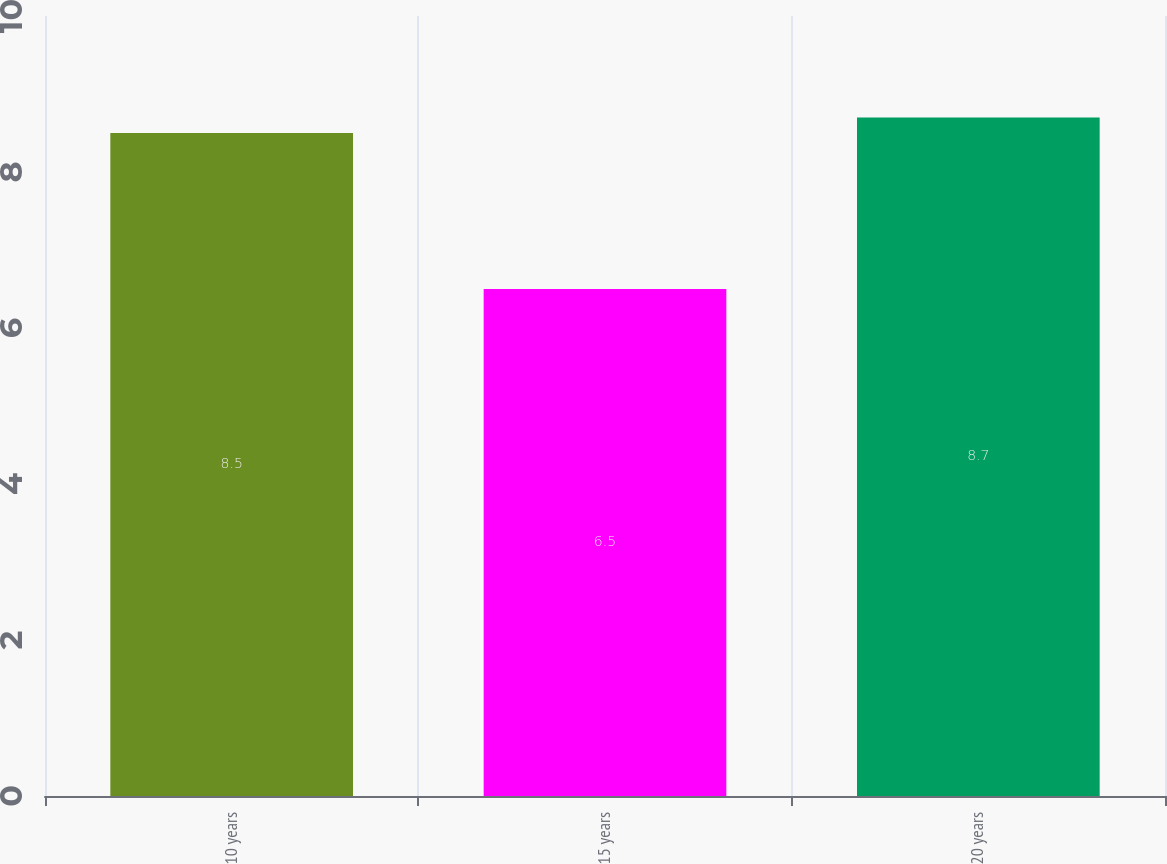Convert chart. <chart><loc_0><loc_0><loc_500><loc_500><bar_chart><fcel>10 years<fcel>15 years<fcel>20 years<nl><fcel>8.5<fcel>6.5<fcel>8.7<nl></chart> 